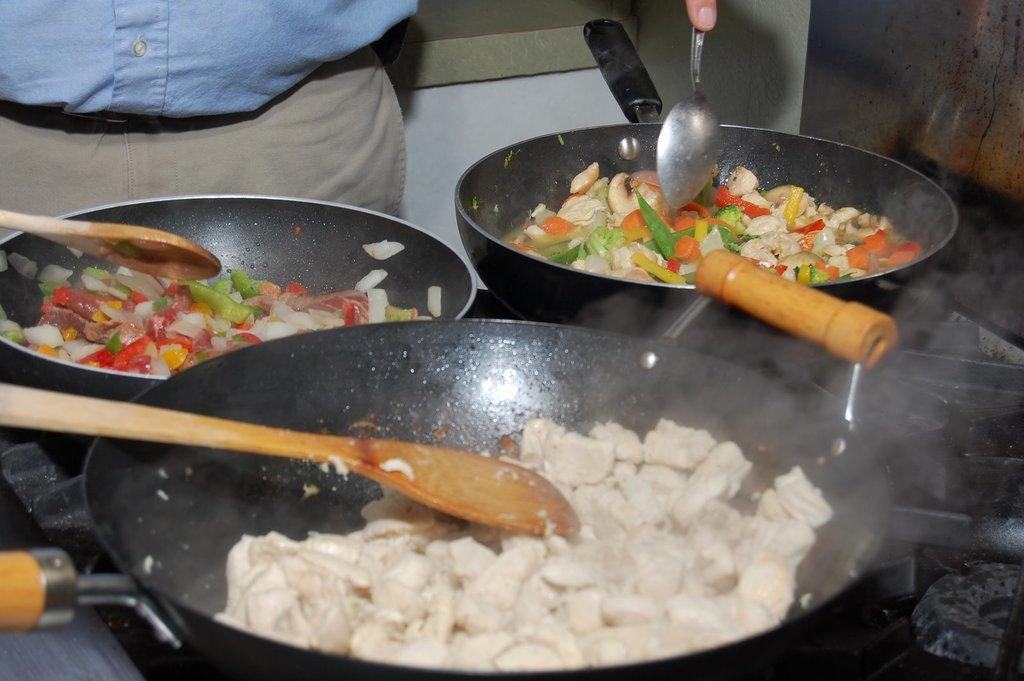What is being cooked in the pans in the image? There are food items in pans in the image. Where are the pans located? The pans are on a stove. What utensils are visible in the image? There are spoons visible in the image. Who is holding a spoon in the image? There is a person holding a spoon in the image. What type of doll is sitting on the stove in the image? There is no doll present in the image; it features food items in pans on a stove. 